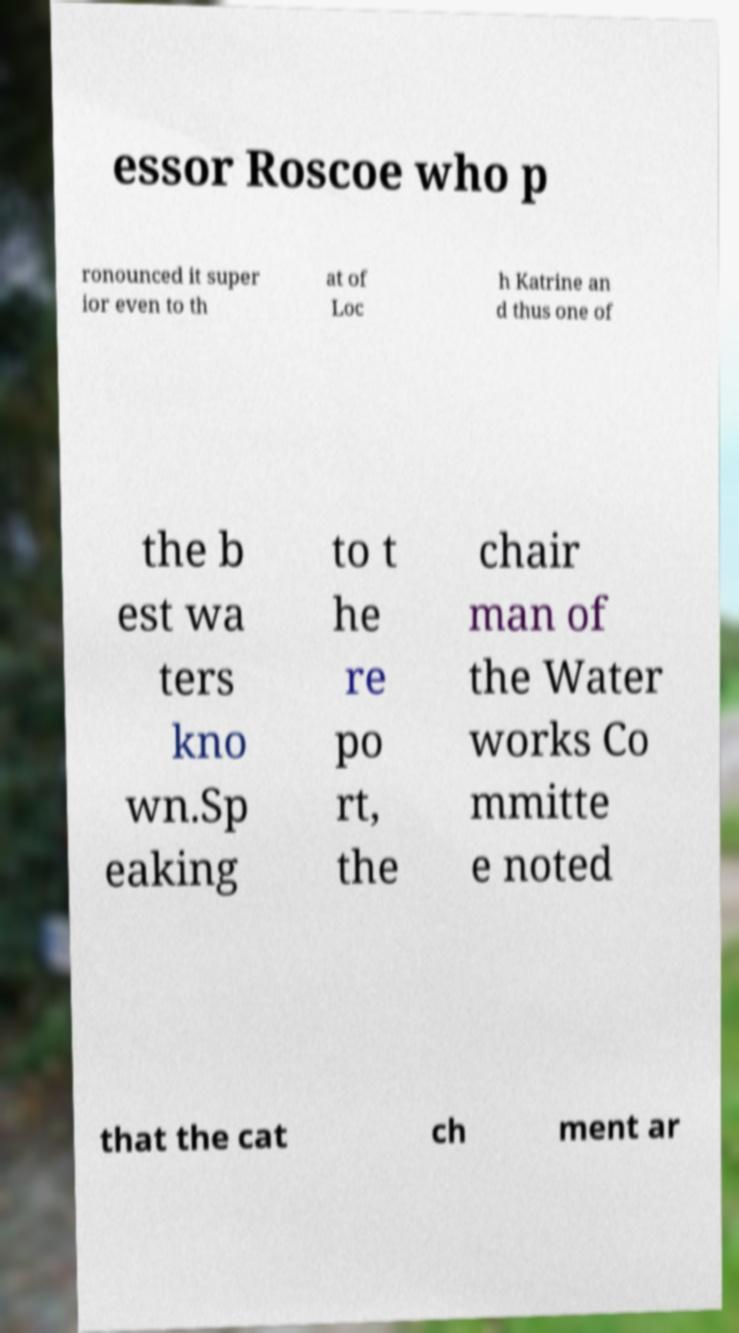Can you accurately transcribe the text from the provided image for me? essor Roscoe who p ronounced it super ior even to th at of Loc h Katrine an d thus one of the b est wa ters kno wn.Sp eaking to t he re po rt, the chair man of the Water works Co mmitte e noted that the cat ch ment ar 